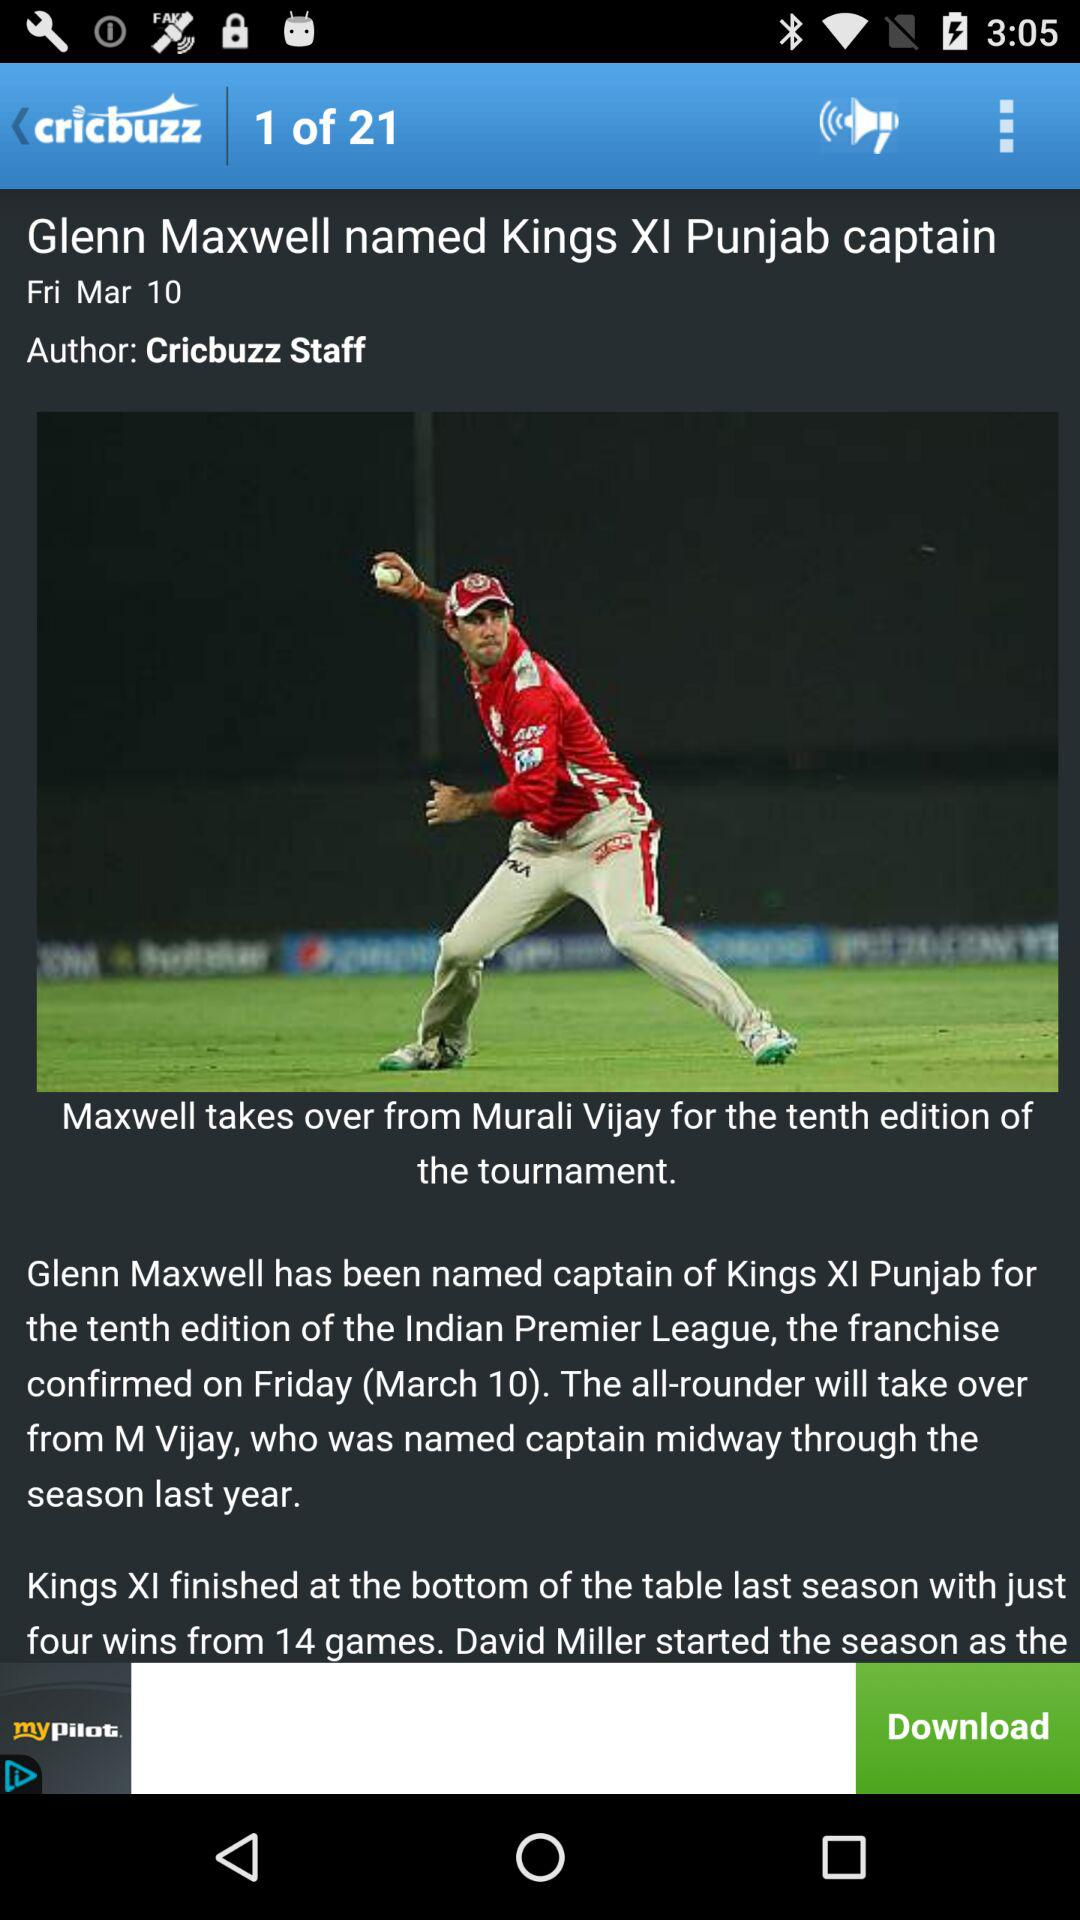When is the news posted? The news was posted on Friday, 10th March. 